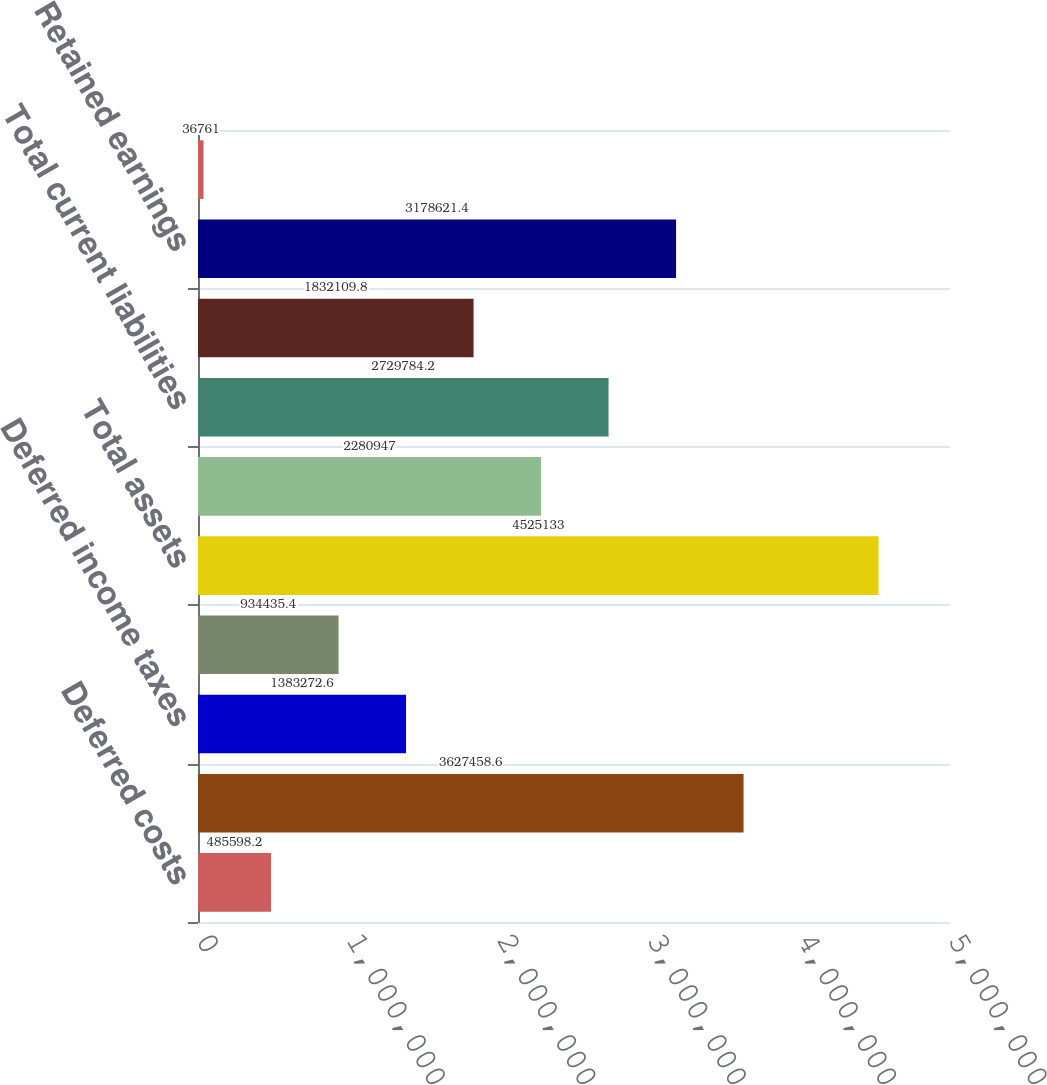<chart> <loc_0><loc_0><loc_500><loc_500><bar_chart><fcel>Deferred costs<fcel>Total current assets<fcel>Deferred income taxes<fcel>Noncurrent deferred costs<fcel>Total assets<fcel>Deferred revenue<fcel>Total current liabilities<fcel>Non - current deferred revenue<fcel>Retained earnings<fcel>Accumulated other<nl><fcel>485598<fcel>3.62746e+06<fcel>1.38327e+06<fcel>934435<fcel>4.52513e+06<fcel>2.28095e+06<fcel>2.72978e+06<fcel>1.83211e+06<fcel>3.17862e+06<fcel>36761<nl></chart> 